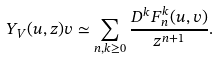<formula> <loc_0><loc_0><loc_500><loc_500>Y _ { V } ( u , z ) v \simeq \sum _ { n , k \geq 0 } \frac { D ^ { k } F _ { n } ^ { k } ( u , v ) } { z ^ { n + 1 } } .</formula> 